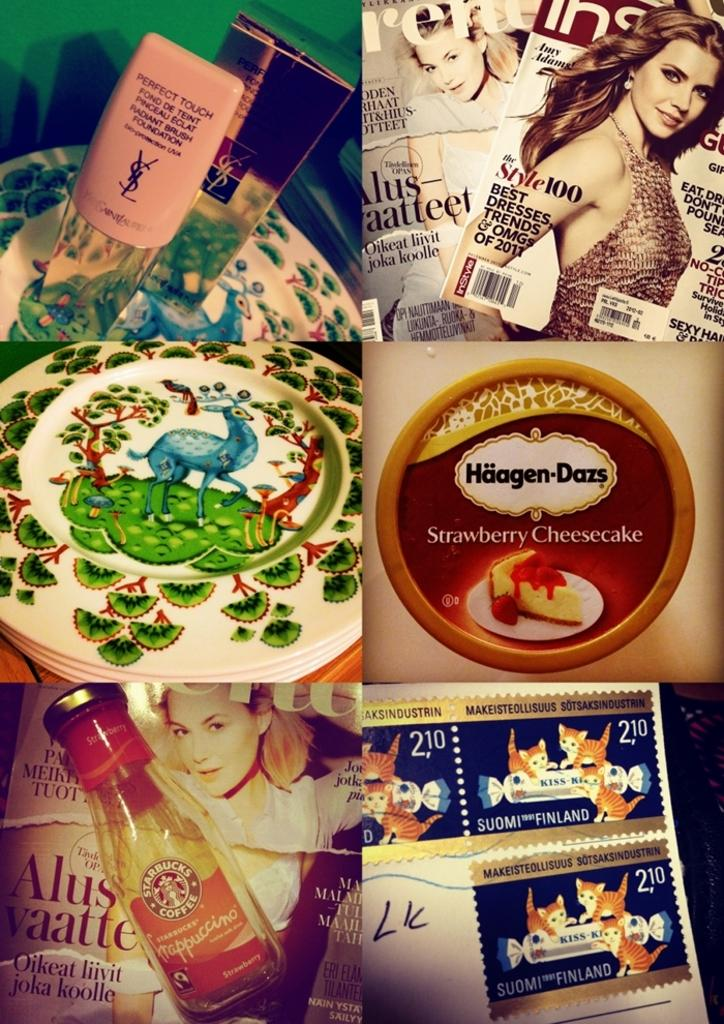<image>
Relay a brief, clear account of the picture shown. Six display grid with the brands YSL, Instyle, a decorative plate, Haagen-Dazs, Starbucks, and a fox stamp 